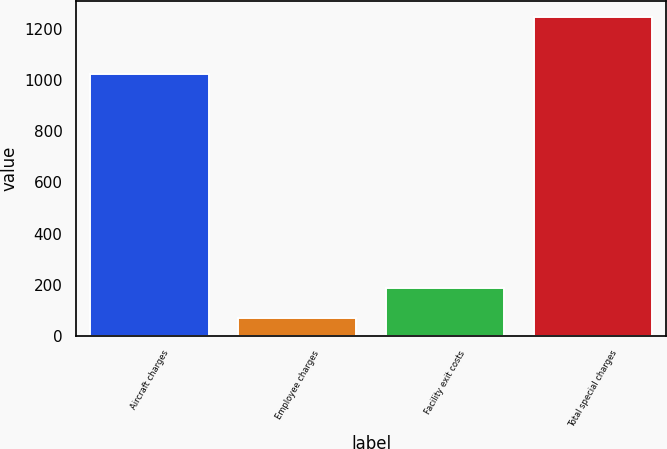Convert chart. <chart><loc_0><loc_0><loc_500><loc_500><bar_chart><fcel>Aircraft charges<fcel>Employee charges<fcel>Facility exit costs<fcel>Total special charges<nl><fcel>1025<fcel>69<fcel>186.9<fcel>1248<nl></chart> 